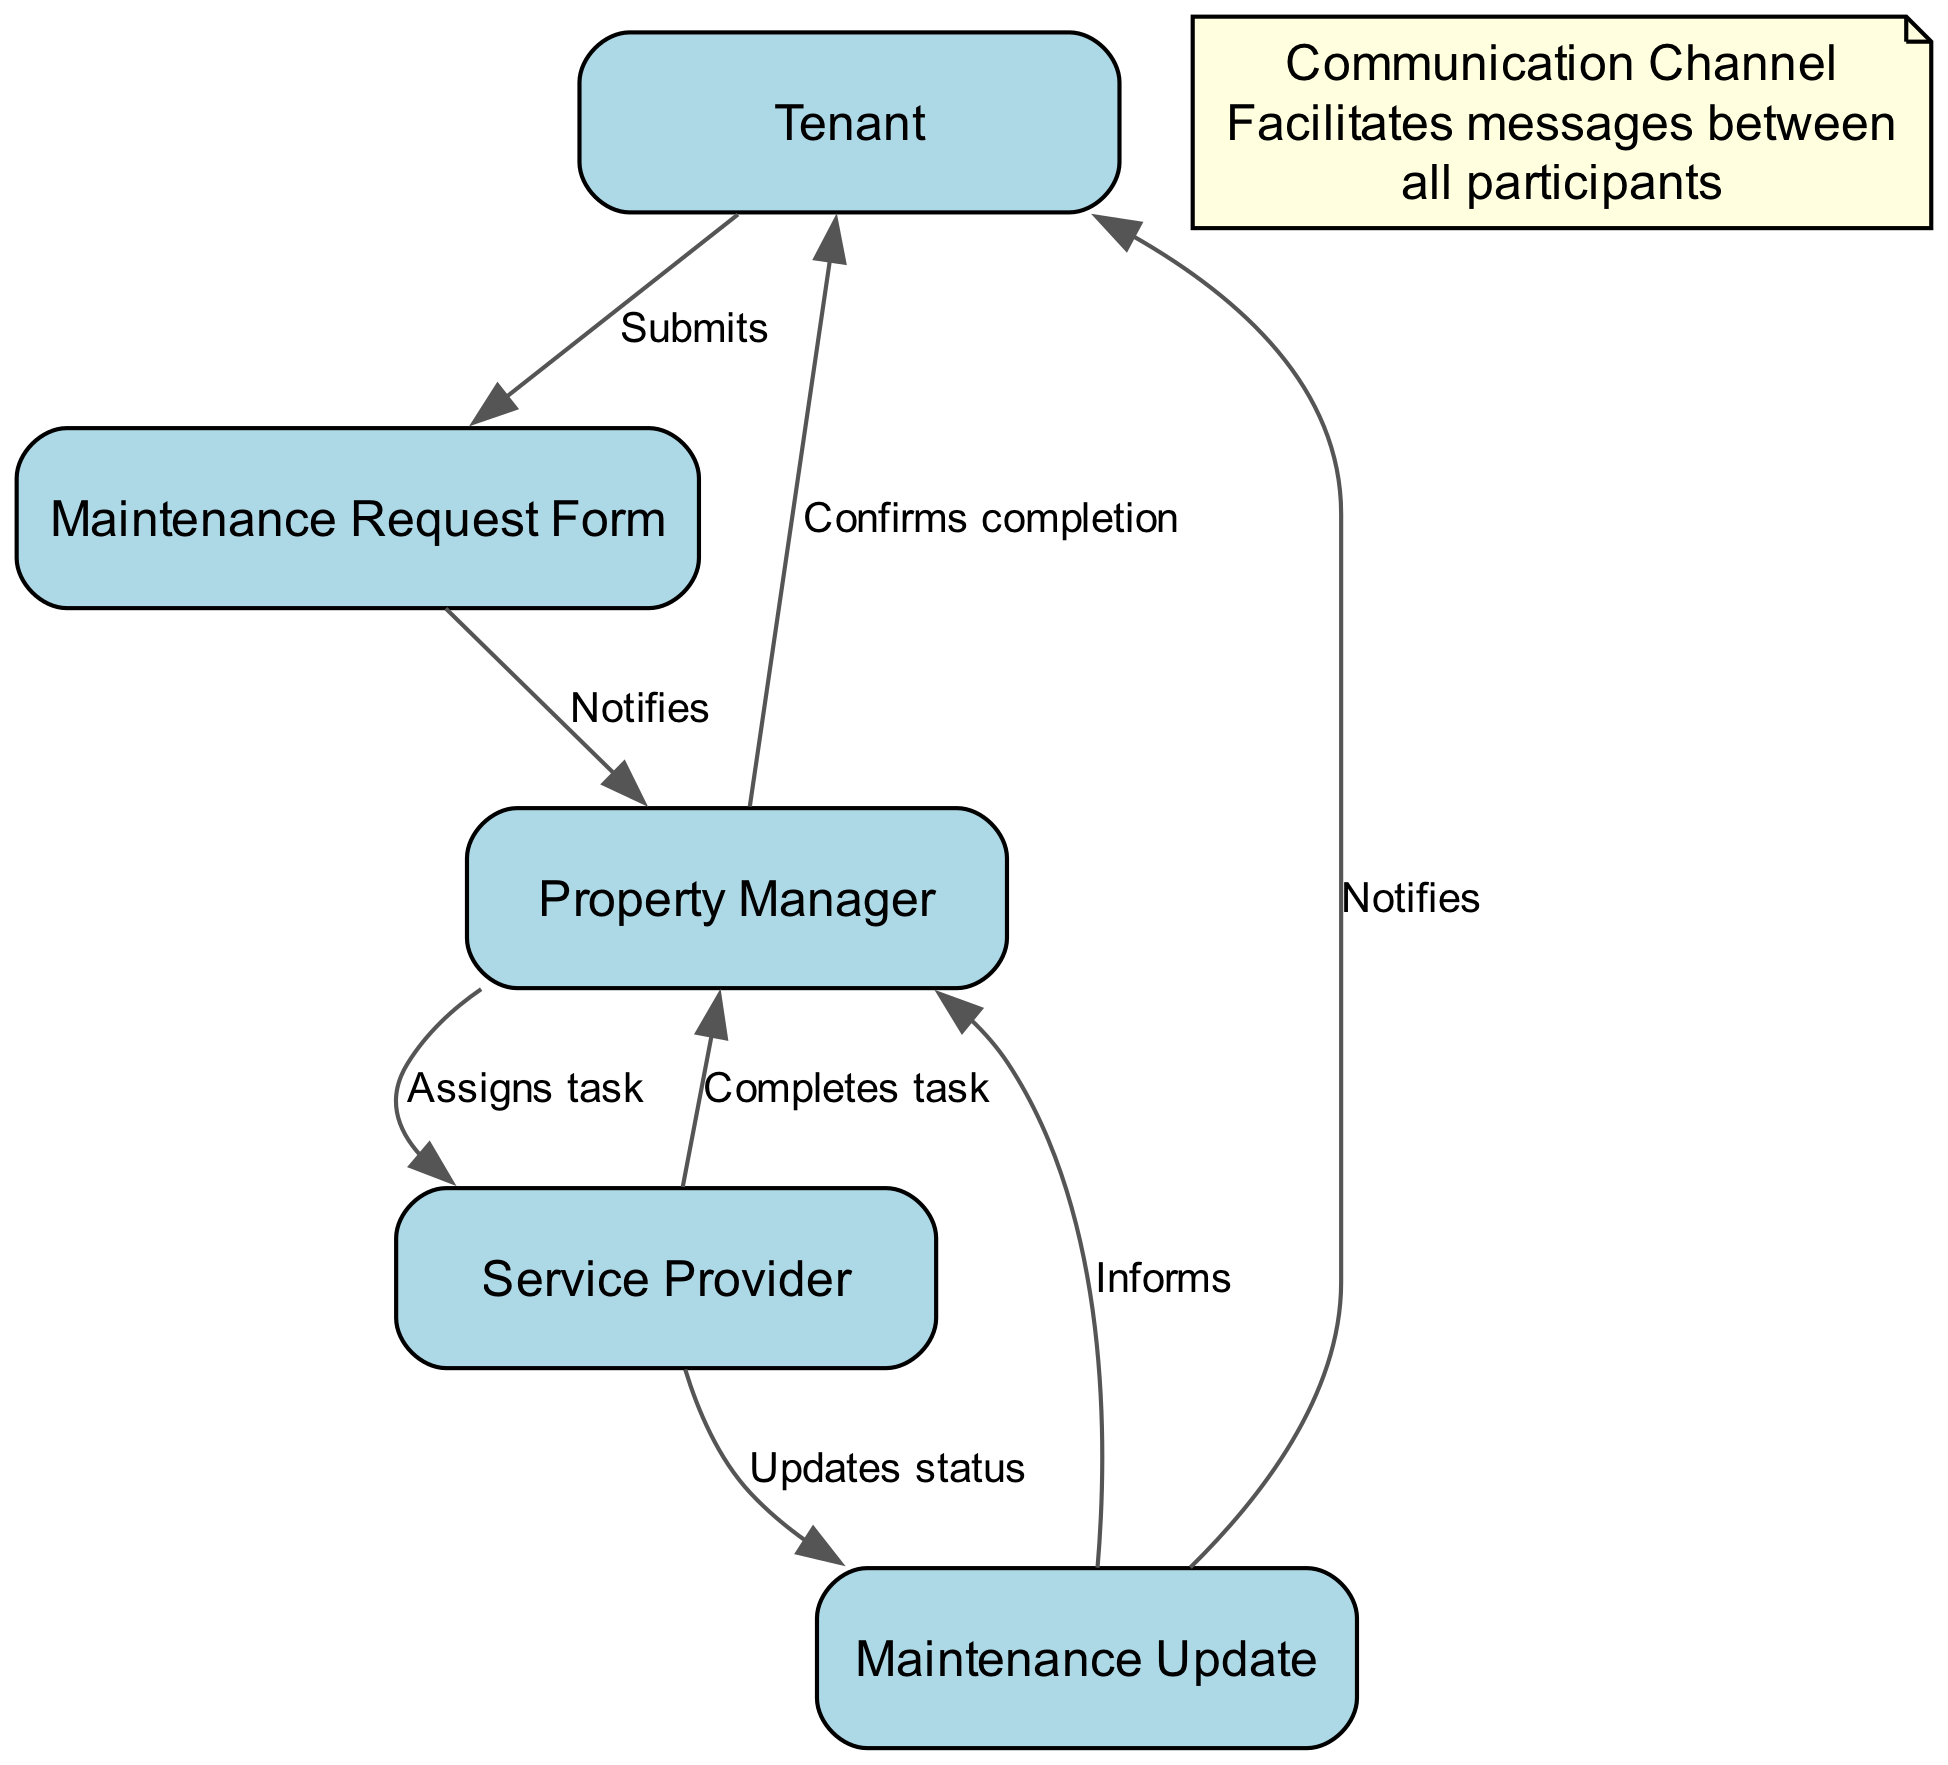What's the first action taken in the sequence? The first action is initiated by the Tenant who submits a maintenance request. This is the starting point of the sequence, which is clearly indicated in the diagram.
Answer: Submits How many nodes are involved in the maintenance request sequence? The diagram contains six nodes: Tenant, Property Manager, Service Provider, Maintenance Request Form, Maintenance Update, and Communication Channel. Counting these participants gives us the total number of nodes.
Answer: Six Who receives the maintenance request form? The maintenance request form is sent to the Property Manager after submission by the Tenant. The flow of the diagram clearly indicates this communication.
Answer: Property Manager What updates does the service provider send? The service provider sends Maintenance Updates which includes status updates on the completion of the maintenance task. This is explicitly labeled as the service provider's action in the sequence.
Answer: Updates status What is the role of the communication channel? The communication channel facilitates messages between all participants in the sequence, allowing for coordination and notifying them throughout the process. This role is indicated as a note in the diagram.
Answer: Facilitates messages What does the property manager do after receiving the maintenance request form? After receiving the maintenance request form, the property manager assigns the task to the service provider. The flow from the Property Manager to the Service Provider indicates this action clearly.
Answer: Assigns task How many notifications does the tenant receive in the process? The tenant receives two notifications throughout the process: one when the maintenance update is sent and another when the task completion is confirmed by the property manager. This is derived from the flow towards the Tenant from the Maintenance Update and Property Manager.
Answer: Two What is the final confirmation action in the sequence? The final confirmation action occurs when the property manager confirms the completion of the maintenance task to the tenant. This is shown as the last link in the sequence.
Answer: Confirms completion 